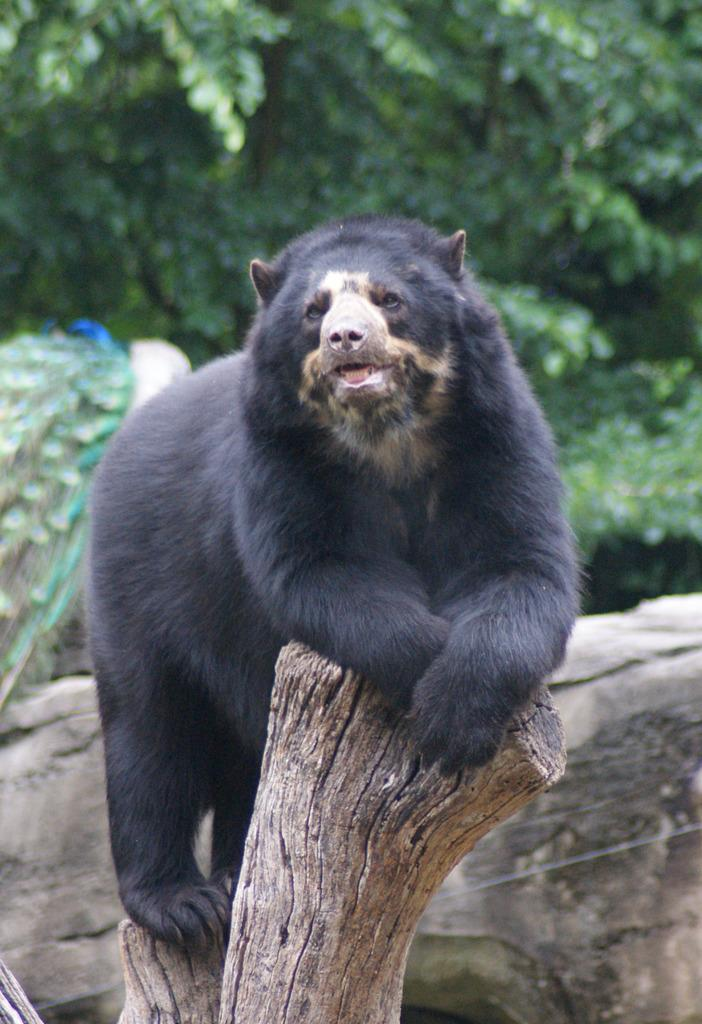What type of creature is in the image? There is an animal in the image. What is the animal standing on? The animal is standing on a wooden brick of a tree. What can be seen in the background of the image? There are trees in the background of the image. Can you see the animal smiling in the image? There is no indication of the animal's facial expression in the image, so it cannot be determined if the animal is smiling. 